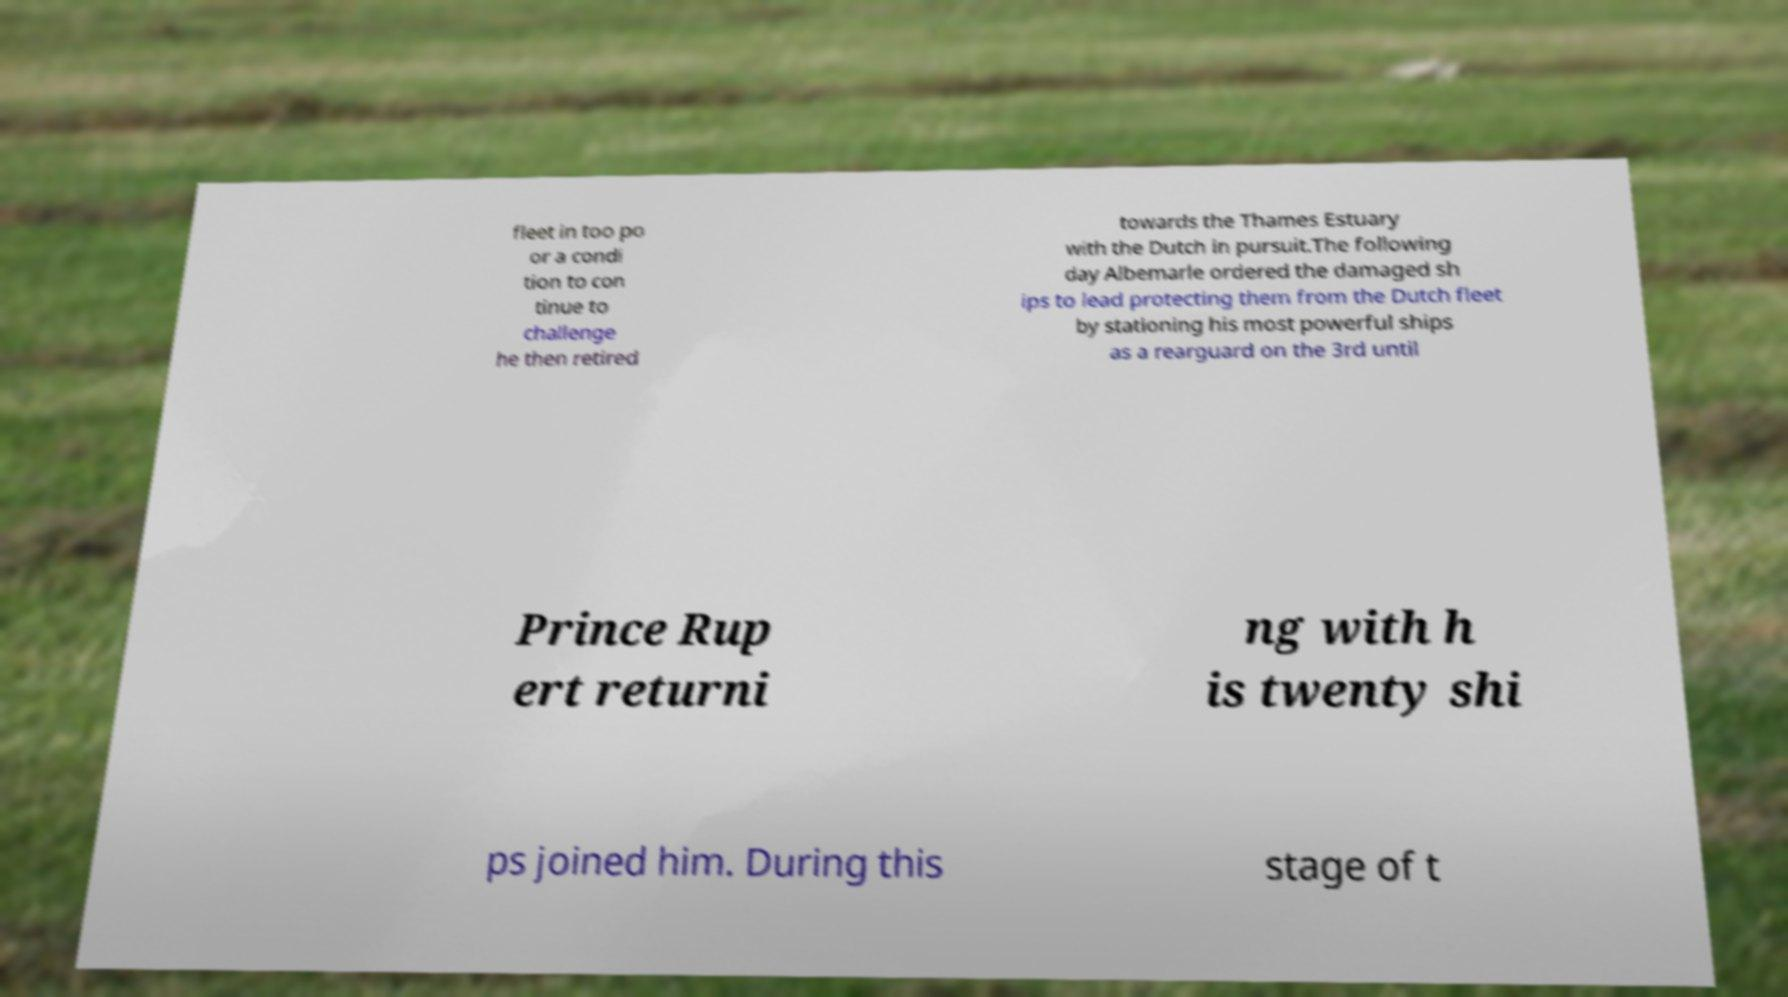Please read and relay the text visible in this image. What does it say? fleet in too po or a condi tion to con tinue to challenge he then retired towards the Thames Estuary with the Dutch in pursuit.The following day Albemarle ordered the damaged sh ips to lead protecting them from the Dutch fleet by stationing his most powerful ships as a rearguard on the 3rd until Prince Rup ert returni ng with h is twenty shi ps joined him. During this stage of t 